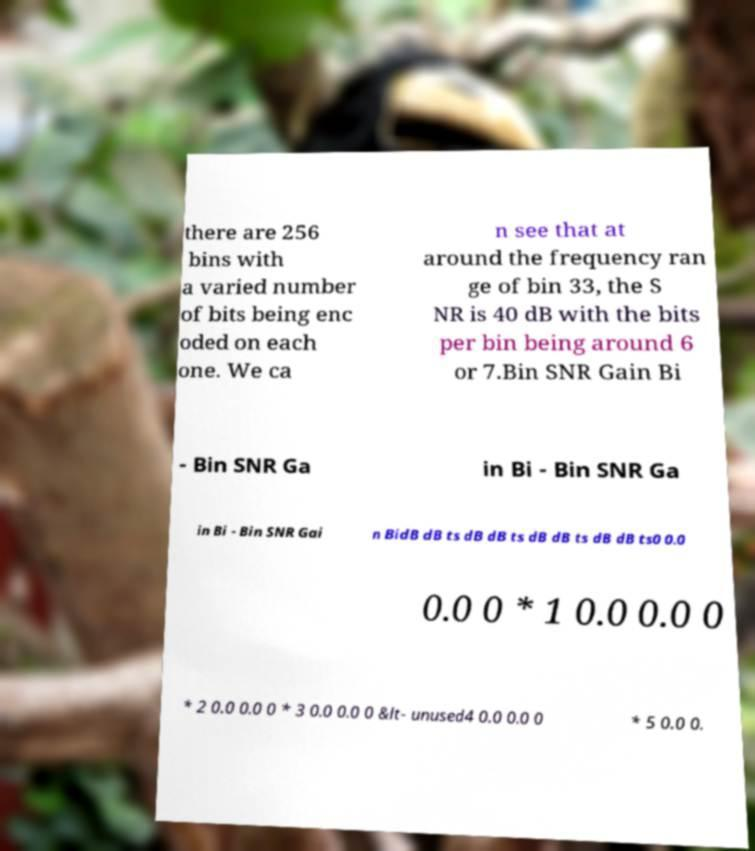Please identify and transcribe the text found in this image. there are 256 bins with a varied number of bits being enc oded on each one. We ca n see that at around the frequency ran ge of bin 33, the S NR is 40 dB with the bits per bin being around 6 or 7.Bin SNR Gain Bi - Bin SNR Ga in Bi - Bin SNR Ga in Bi - Bin SNR Gai n BidB dB ts dB dB ts dB dB ts dB dB ts0 0.0 0.0 0 * 1 0.0 0.0 0 * 2 0.0 0.0 0 * 3 0.0 0.0 0 &lt- unused4 0.0 0.0 0 * 5 0.0 0. 